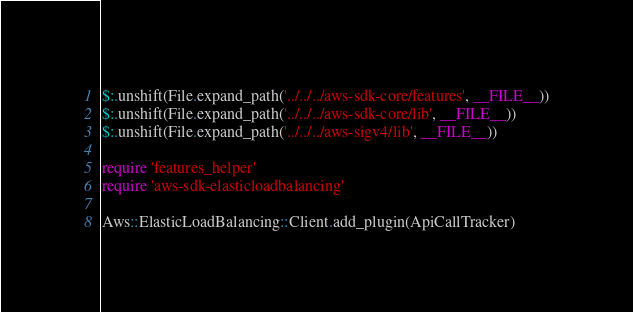Convert code to text. <code><loc_0><loc_0><loc_500><loc_500><_Ruby_>$:.unshift(File.expand_path('../../../aws-sdk-core/features', __FILE__))
$:.unshift(File.expand_path('../../../aws-sdk-core/lib', __FILE__))
$:.unshift(File.expand_path('../../../aws-sigv4/lib', __FILE__))

require 'features_helper'
require 'aws-sdk-elasticloadbalancing'

Aws::ElasticLoadBalancing::Client.add_plugin(ApiCallTracker)
</code> 